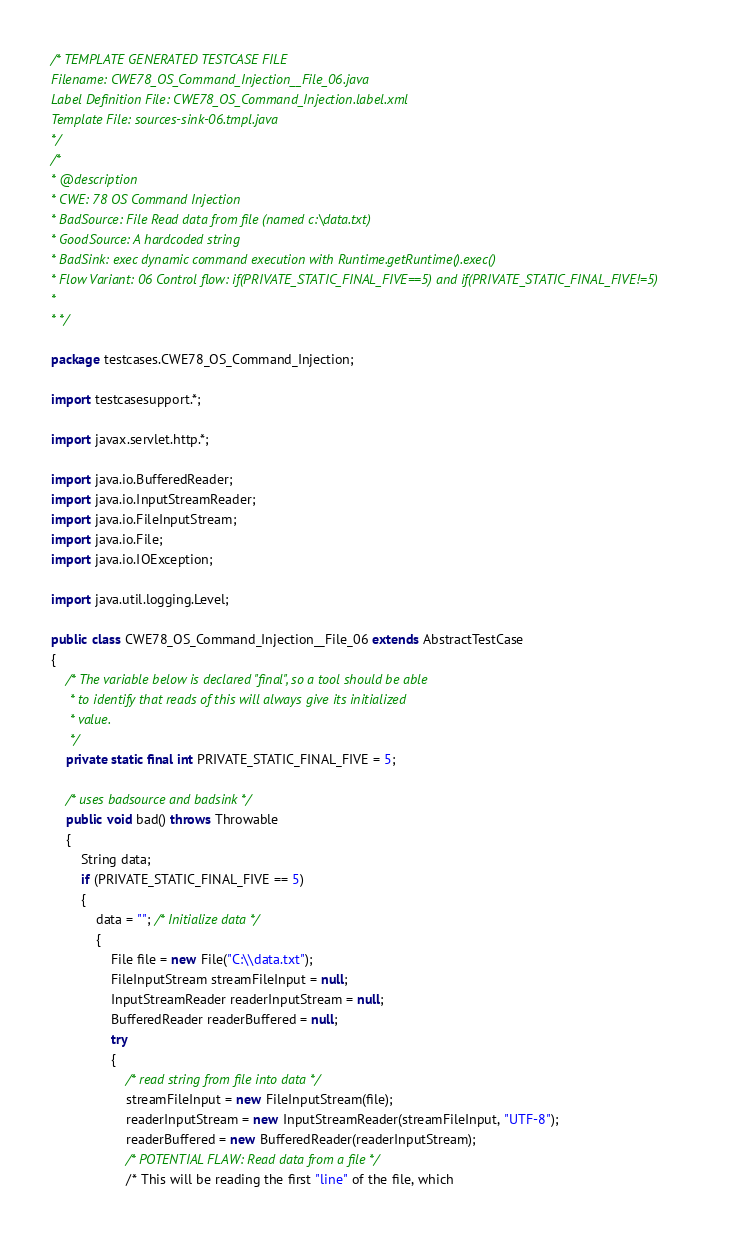Convert code to text. <code><loc_0><loc_0><loc_500><loc_500><_Java_>/* TEMPLATE GENERATED TESTCASE FILE
Filename: CWE78_OS_Command_Injection__File_06.java
Label Definition File: CWE78_OS_Command_Injection.label.xml
Template File: sources-sink-06.tmpl.java
*/
/*
* @description
* CWE: 78 OS Command Injection
* BadSource: File Read data from file (named c:\data.txt)
* GoodSource: A hardcoded string
* BadSink: exec dynamic command execution with Runtime.getRuntime().exec()
* Flow Variant: 06 Control flow: if(PRIVATE_STATIC_FINAL_FIVE==5) and if(PRIVATE_STATIC_FINAL_FIVE!=5)
*
* */

package testcases.CWE78_OS_Command_Injection;

import testcasesupport.*;

import javax.servlet.http.*;

import java.io.BufferedReader;
import java.io.InputStreamReader;
import java.io.FileInputStream;
import java.io.File;
import java.io.IOException;

import java.util.logging.Level;

public class CWE78_OS_Command_Injection__File_06 extends AbstractTestCase
{
    /* The variable below is declared "final", so a tool should be able
     * to identify that reads of this will always give its initialized
     * value.
     */
    private static final int PRIVATE_STATIC_FINAL_FIVE = 5;

    /* uses badsource and badsink */
    public void bad() throws Throwable
    {
        String data;
        if (PRIVATE_STATIC_FINAL_FIVE == 5)
        {
            data = ""; /* Initialize data */
            {
                File file = new File("C:\\data.txt");
                FileInputStream streamFileInput = null;
                InputStreamReader readerInputStream = null;
                BufferedReader readerBuffered = null;
                try
                {
                    /* read string from file into data */
                    streamFileInput = new FileInputStream(file);
                    readerInputStream = new InputStreamReader(streamFileInput, "UTF-8");
                    readerBuffered = new BufferedReader(readerInputStream);
                    /* POTENTIAL FLAW: Read data from a file */
                    /* This will be reading the first "line" of the file, which</code> 